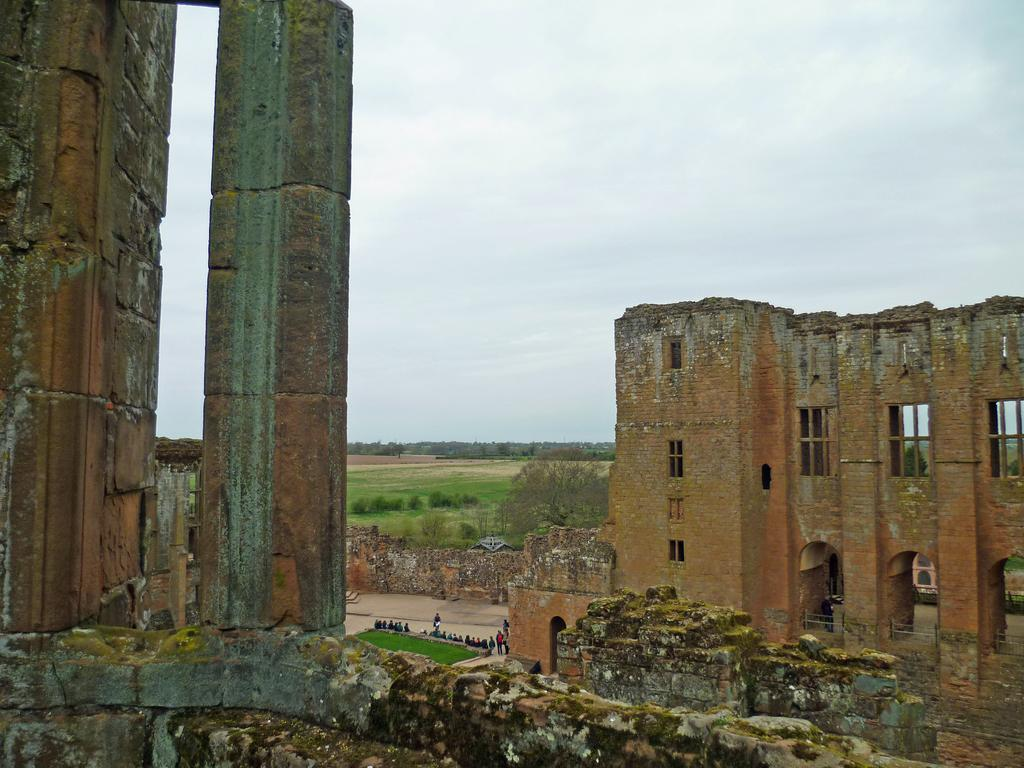What type of structures can be seen in the image? There are buildings with windows in the image. What type of vegetation is present in the image? There is grass and trees in the image. What is the group of people doing in the image? The group of people is on the ground in the image. What is visible in the background of the image? The sky is visible in the background of the image. What can be observed in the sky? Clouds are present in the sky. What songs are being sung by the trees in the image? There are no songs being sung by the trees in the image, as trees do not have the ability to sing. How is the property divided among the buildings in the image? There is no information about property division in the image, as it only shows buildings, trees, grass, and a group of people. 